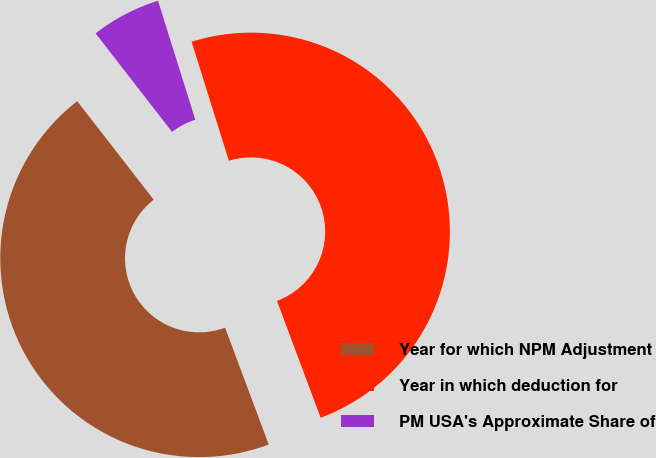Convert chart to OTSL. <chart><loc_0><loc_0><loc_500><loc_500><pie_chart><fcel>Year for which NPM Adjustment<fcel>Year in which deduction for<fcel>PM USA's Approximate Share of<nl><fcel>45.19%<fcel>49.14%<fcel>5.67%<nl></chart> 